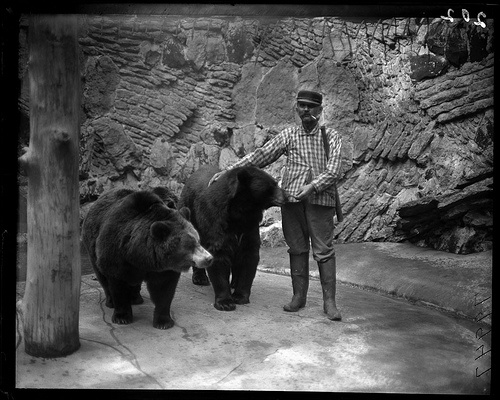Describe the objects in this image and their specific colors. I can see bear in black, gray, darkgray, and lightgray tones, people in black, gray, darkgray, and lightgray tones, bear in black, gray, darkgray, and lightgray tones, and handbag in black, gray, and lightgray tones in this image. 